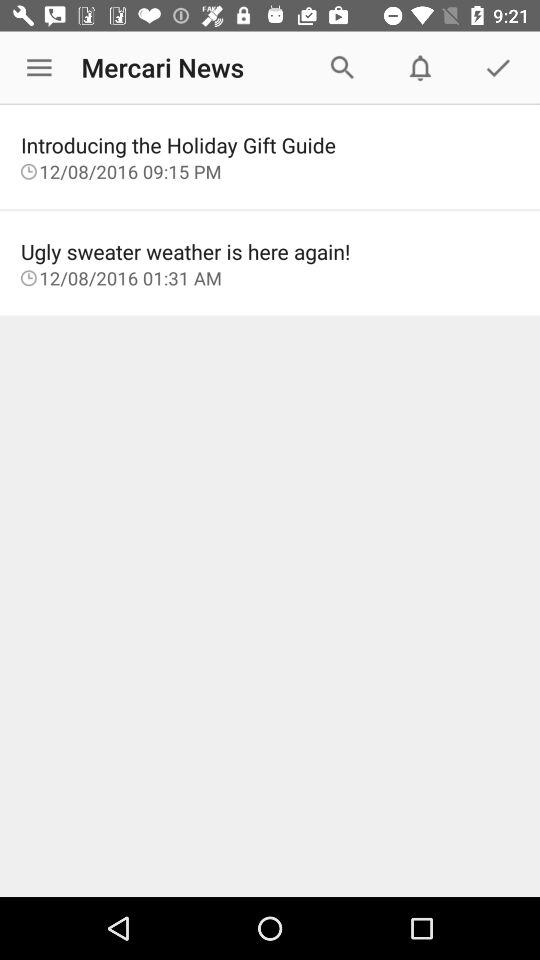What is the application name? The application name is "Mercari News". 